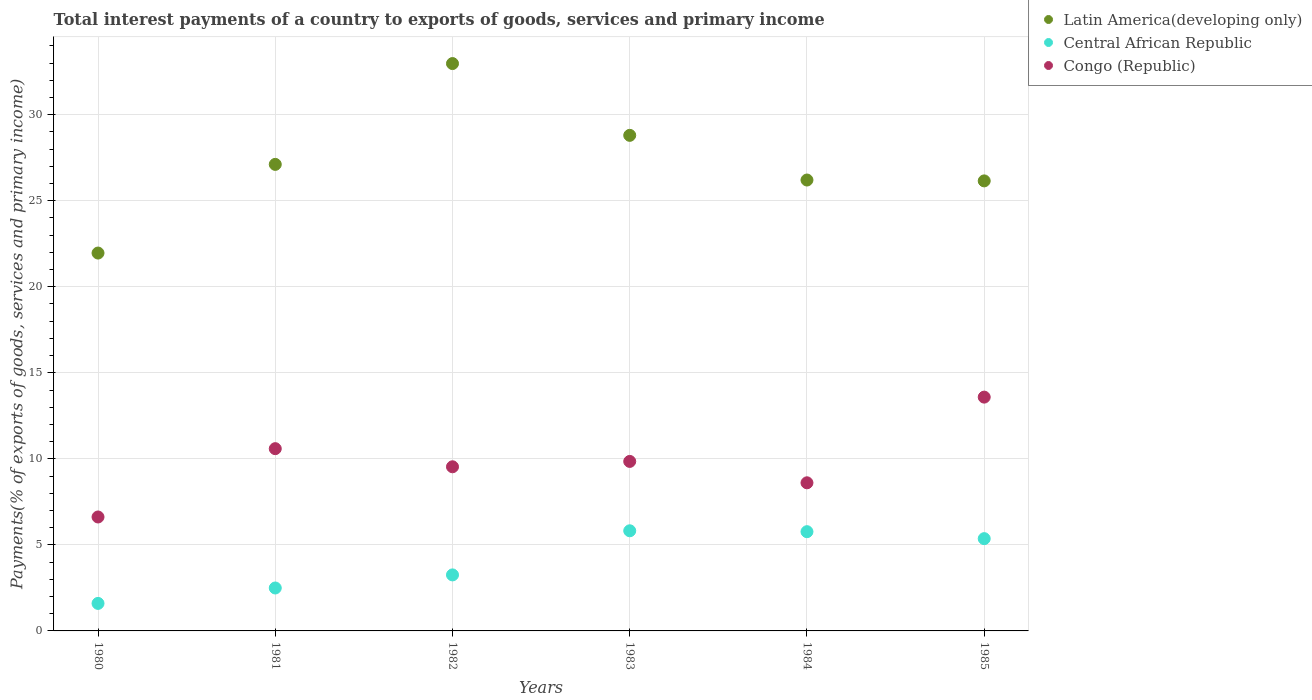What is the total interest payments in Central African Republic in 1984?
Offer a terse response. 5.77. Across all years, what is the maximum total interest payments in Congo (Republic)?
Your response must be concise. 13.59. Across all years, what is the minimum total interest payments in Latin America(developing only)?
Ensure brevity in your answer.  21.96. In which year was the total interest payments in Congo (Republic) minimum?
Your answer should be very brief. 1980. What is the total total interest payments in Congo (Republic) in the graph?
Give a very brief answer. 58.8. What is the difference between the total interest payments in Central African Republic in 1980 and that in 1981?
Your response must be concise. -0.9. What is the difference between the total interest payments in Congo (Republic) in 1984 and the total interest payments in Central African Republic in 1981?
Offer a very short reply. 6.11. What is the average total interest payments in Central African Republic per year?
Your response must be concise. 4.05. In the year 1980, what is the difference between the total interest payments in Latin America(developing only) and total interest payments in Congo (Republic)?
Give a very brief answer. 15.34. In how many years, is the total interest payments in Central African Republic greater than 22 %?
Provide a short and direct response. 0. What is the ratio of the total interest payments in Central African Republic in 1984 to that in 1985?
Give a very brief answer. 1.08. Is the total interest payments in Congo (Republic) in 1980 less than that in 1985?
Your response must be concise. Yes. Is the difference between the total interest payments in Latin America(developing only) in 1982 and 1985 greater than the difference between the total interest payments in Congo (Republic) in 1982 and 1985?
Ensure brevity in your answer.  Yes. What is the difference between the highest and the second highest total interest payments in Latin America(developing only)?
Provide a succinct answer. 4.17. What is the difference between the highest and the lowest total interest payments in Congo (Republic)?
Keep it short and to the point. 6.97. In how many years, is the total interest payments in Latin America(developing only) greater than the average total interest payments in Latin America(developing only) taken over all years?
Offer a very short reply. 2. Is it the case that in every year, the sum of the total interest payments in Central African Republic and total interest payments in Latin America(developing only)  is greater than the total interest payments in Congo (Republic)?
Offer a very short reply. Yes. Does the total interest payments in Central African Republic monotonically increase over the years?
Your response must be concise. No. Is the total interest payments in Latin America(developing only) strictly less than the total interest payments in Central African Republic over the years?
Make the answer very short. No. Does the graph contain any zero values?
Provide a succinct answer. No. Where does the legend appear in the graph?
Provide a succinct answer. Top right. How many legend labels are there?
Ensure brevity in your answer.  3. How are the legend labels stacked?
Offer a very short reply. Vertical. What is the title of the graph?
Your response must be concise. Total interest payments of a country to exports of goods, services and primary income. What is the label or title of the X-axis?
Provide a succinct answer. Years. What is the label or title of the Y-axis?
Give a very brief answer. Payments(% of exports of goods, services and primary income). What is the Payments(% of exports of goods, services and primary income) in Latin America(developing only) in 1980?
Give a very brief answer. 21.96. What is the Payments(% of exports of goods, services and primary income) of Central African Republic in 1980?
Offer a very short reply. 1.6. What is the Payments(% of exports of goods, services and primary income) of Congo (Republic) in 1980?
Provide a short and direct response. 6.62. What is the Payments(% of exports of goods, services and primary income) of Latin America(developing only) in 1981?
Your response must be concise. 27.11. What is the Payments(% of exports of goods, services and primary income) in Central African Republic in 1981?
Provide a succinct answer. 2.5. What is the Payments(% of exports of goods, services and primary income) of Congo (Republic) in 1981?
Your answer should be very brief. 10.59. What is the Payments(% of exports of goods, services and primary income) of Latin America(developing only) in 1982?
Offer a very short reply. 32.97. What is the Payments(% of exports of goods, services and primary income) of Central African Republic in 1982?
Make the answer very short. 3.26. What is the Payments(% of exports of goods, services and primary income) in Congo (Republic) in 1982?
Offer a very short reply. 9.54. What is the Payments(% of exports of goods, services and primary income) in Latin America(developing only) in 1983?
Your answer should be very brief. 28.8. What is the Payments(% of exports of goods, services and primary income) in Central African Republic in 1983?
Offer a very short reply. 5.82. What is the Payments(% of exports of goods, services and primary income) in Congo (Republic) in 1983?
Provide a succinct answer. 9.85. What is the Payments(% of exports of goods, services and primary income) of Latin America(developing only) in 1984?
Give a very brief answer. 26.2. What is the Payments(% of exports of goods, services and primary income) of Central African Republic in 1984?
Ensure brevity in your answer.  5.77. What is the Payments(% of exports of goods, services and primary income) of Congo (Republic) in 1984?
Make the answer very short. 8.61. What is the Payments(% of exports of goods, services and primary income) in Latin America(developing only) in 1985?
Ensure brevity in your answer.  26.15. What is the Payments(% of exports of goods, services and primary income) in Central African Republic in 1985?
Offer a terse response. 5.36. What is the Payments(% of exports of goods, services and primary income) of Congo (Republic) in 1985?
Your answer should be compact. 13.59. Across all years, what is the maximum Payments(% of exports of goods, services and primary income) in Latin America(developing only)?
Your answer should be compact. 32.97. Across all years, what is the maximum Payments(% of exports of goods, services and primary income) of Central African Republic?
Provide a succinct answer. 5.82. Across all years, what is the maximum Payments(% of exports of goods, services and primary income) of Congo (Republic)?
Keep it short and to the point. 13.59. Across all years, what is the minimum Payments(% of exports of goods, services and primary income) in Latin America(developing only)?
Your answer should be compact. 21.96. Across all years, what is the minimum Payments(% of exports of goods, services and primary income) of Central African Republic?
Ensure brevity in your answer.  1.6. Across all years, what is the minimum Payments(% of exports of goods, services and primary income) in Congo (Republic)?
Offer a very short reply. 6.62. What is the total Payments(% of exports of goods, services and primary income) of Latin America(developing only) in the graph?
Your response must be concise. 163.21. What is the total Payments(% of exports of goods, services and primary income) of Central African Republic in the graph?
Your response must be concise. 24.3. What is the total Payments(% of exports of goods, services and primary income) of Congo (Republic) in the graph?
Make the answer very short. 58.8. What is the difference between the Payments(% of exports of goods, services and primary income) in Latin America(developing only) in 1980 and that in 1981?
Your answer should be very brief. -5.15. What is the difference between the Payments(% of exports of goods, services and primary income) in Central African Republic in 1980 and that in 1981?
Ensure brevity in your answer.  -0.9. What is the difference between the Payments(% of exports of goods, services and primary income) in Congo (Republic) in 1980 and that in 1981?
Your answer should be very brief. -3.97. What is the difference between the Payments(% of exports of goods, services and primary income) in Latin America(developing only) in 1980 and that in 1982?
Give a very brief answer. -11.01. What is the difference between the Payments(% of exports of goods, services and primary income) of Central African Republic in 1980 and that in 1982?
Your answer should be very brief. -1.66. What is the difference between the Payments(% of exports of goods, services and primary income) of Congo (Republic) in 1980 and that in 1982?
Your answer should be compact. -2.92. What is the difference between the Payments(% of exports of goods, services and primary income) in Latin America(developing only) in 1980 and that in 1983?
Offer a terse response. -6.84. What is the difference between the Payments(% of exports of goods, services and primary income) of Central African Republic in 1980 and that in 1983?
Your answer should be compact. -4.22. What is the difference between the Payments(% of exports of goods, services and primary income) of Congo (Republic) in 1980 and that in 1983?
Offer a terse response. -3.23. What is the difference between the Payments(% of exports of goods, services and primary income) of Latin America(developing only) in 1980 and that in 1984?
Ensure brevity in your answer.  -4.24. What is the difference between the Payments(% of exports of goods, services and primary income) in Central African Republic in 1980 and that in 1984?
Ensure brevity in your answer.  -4.17. What is the difference between the Payments(% of exports of goods, services and primary income) in Congo (Republic) in 1980 and that in 1984?
Ensure brevity in your answer.  -1.99. What is the difference between the Payments(% of exports of goods, services and primary income) of Latin America(developing only) in 1980 and that in 1985?
Provide a succinct answer. -4.19. What is the difference between the Payments(% of exports of goods, services and primary income) of Central African Republic in 1980 and that in 1985?
Your answer should be compact. -3.76. What is the difference between the Payments(% of exports of goods, services and primary income) of Congo (Republic) in 1980 and that in 1985?
Ensure brevity in your answer.  -6.97. What is the difference between the Payments(% of exports of goods, services and primary income) in Latin America(developing only) in 1981 and that in 1982?
Offer a very short reply. -5.86. What is the difference between the Payments(% of exports of goods, services and primary income) of Central African Republic in 1981 and that in 1982?
Your response must be concise. -0.76. What is the difference between the Payments(% of exports of goods, services and primary income) in Congo (Republic) in 1981 and that in 1982?
Your answer should be very brief. 1.05. What is the difference between the Payments(% of exports of goods, services and primary income) of Latin America(developing only) in 1981 and that in 1983?
Offer a very short reply. -1.69. What is the difference between the Payments(% of exports of goods, services and primary income) of Central African Republic in 1981 and that in 1983?
Give a very brief answer. -3.32. What is the difference between the Payments(% of exports of goods, services and primary income) in Congo (Republic) in 1981 and that in 1983?
Offer a very short reply. 0.74. What is the difference between the Payments(% of exports of goods, services and primary income) of Central African Republic in 1981 and that in 1984?
Offer a terse response. -3.27. What is the difference between the Payments(% of exports of goods, services and primary income) of Congo (Republic) in 1981 and that in 1984?
Provide a succinct answer. 1.98. What is the difference between the Payments(% of exports of goods, services and primary income) of Latin America(developing only) in 1981 and that in 1985?
Offer a very short reply. 0.96. What is the difference between the Payments(% of exports of goods, services and primary income) of Central African Republic in 1981 and that in 1985?
Your answer should be compact. -2.87. What is the difference between the Payments(% of exports of goods, services and primary income) in Congo (Republic) in 1981 and that in 1985?
Keep it short and to the point. -3. What is the difference between the Payments(% of exports of goods, services and primary income) in Latin America(developing only) in 1982 and that in 1983?
Offer a very short reply. 4.17. What is the difference between the Payments(% of exports of goods, services and primary income) in Central African Republic in 1982 and that in 1983?
Ensure brevity in your answer.  -2.56. What is the difference between the Payments(% of exports of goods, services and primary income) in Congo (Republic) in 1982 and that in 1983?
Offer a terse response. -0.31. What is the difference between the Payments(% of exports of goods, services and primary income) of Latin America(developing only) in 1982 and that in 1984?
Keep it short and to the point. 6.77. What is the difference between the Payments(% of exports of goods, services and primary income) of Central African Republic in 1982 and that in 1984?
Your answer should be compact. -2.51. What is the difference between the Payments(% of exports of goods, services and primary income) in Congo (Republic) in 1982 and that in 1984?
Provide a succinct answer. 0.93. What is the difference between the Payments(% of exports of goods, services and primary income) in Latin America(developing only) in 1982 and that in 1985?
Offer a very short reply. 6.82. What is the difference between the Payments(% of exports of goods, services and primary income) in Central African Republic in 1982 and that in 1985?
Your answer should be compact. -2.11. What is the difference between the Payments(% of exports of goods, services and primary income) of Congo (Republic) in 1982 and that in 1985?
Give a very brief answer. -4.05. What is the difference between the Payments(% of exports of goods, services and primary income) of Latin America(developing only) in 1983 and that in 1984?
Make the answer very short. 2.6. What is the difference between the Payments(% of exports of goods, services and primary income) of Central African Republic in 1983 and that in 1984?
Offer a very short reply. 0.05. What is the difference between the Payments(% of exports of goods, services and primary income) in Congo (Republic) in 1983 and that in 1984?
Your answer should be compact. 1.24. What is the difference between the Payments(% of exports of goods, services and primary income) of Latin America(developing only) in 1983 and that in 1985?
Provide a succinct answer. 2.65. What is the difference between the Payments(% of exports of goods, services and primary income) in Central African Republic in 1983 and that in 1985?
Ensure brevity in your answer.  0.46. What is the difference between the Payments(% of exports of goods, services and primary income) of Congo (Republic) in 1983 and that in 1985?
Provide a short and direct response. -3.74. What is the difference between the Payments(% of exports of goods, services and primary income) of Latin America(developing only) in 1984 and that in 1985?
Provide a succinct answer. 0.05. What is the difference between the Payments(% of exports of goods, services and primary income) of Central African Republic in 1984 and that in 1985?
Ensure brevity in your answer.  0.4. What is the difference between the Payments(% of exports of goods, services and primary income) of Congo (Republic) in 1984 and that in 1985?
Offer a terse response. -4.98. What is the difference between the Payments(% of exports of goods, services and primary income) of Latin America(developing only) in 1980 and the Payments(% of exports of goods, services and primary income) of Central African Republic in 1981?
Ensure brevity in your answer.  19.47. What is the difference between the Payments(% of exports of goods, services and primary income) in Latin America(developing only) in 1980 and the Payments(% of exports of goods, services and primary income) in Congo (Republic) in 1981?
Your answer should be compact. 11.37. What is the difference between the Payments(% of exports of goods, services and primary income) of Central African Republic in 1980 and the Payments(% of exports of goods, services and primary income) of Congo (Republic) in 1981?
Your answer should be very brief. -8.99. What is the difference between the Payments(% of exports of goods, services and primary income) of Latin America(developing only) in 1980 and the Payments(% of exports of goods, services and primary income) of Central African Republic in 1982?
Provide a succinct answer. 18.71. What is the difference between the Payments(% of exports of goods, services and primary income) of Latin America(developing only) in 1980 and the Payments(% of exports of goods, services and primary income) of Congo (Republic) in 1982?
Offer a very short reply. 12.42. What is the difference between the Payments(% of exports of goods, services and primary income) in Central African Republic in 1980 and the Payments(% of exports of goods, services and primary income) in Congo (Republic) in 1982?
Make the answer very short. -7.94. What is the difference between the Payments(% of exports of goods, services and primary income) of Latin America(developing only) in 1980 and the Payments(% of exports of goods, services and primary income) of Central African Republic in 1983?
Provide a short and direct response. 16.14. What is the difference between the Payments(% of exports of goods, services and primary income) in Latin America(developing only) in 1980 and the Payments(% of exports of goods, services and primary income) in Congo (Republic) in 1983?
Your response must be concise. 12.11. What is the difference between the Payments(% of exports of goods, services and primary income) of Central African Republic in 1980 and the Payments(% of exports of goods, services and primary income) of Congo (Republic) in 1983?
Ensure brevity in your answer.  -8.25. What is the difference between the Payments(% of exports of goods, services and primary income) of Latin America(developing only) in 1980 and the Payments(% of exports of goods, services and primary income) of Central African Republic in 1984?
Your answer should be very brief. 16.19. What is the difference between the Payments(% of exports of goods, services and primary income) in Latin America(developing only) in 1980 and the Payments(% of exports of goods, services and primary income) in Congo (Republic) in 1984?
Provide a succinct answer. 13.35. What is the difference between the Payments(% of exports of goods, services and primary income) in Central African Republic in 1980 and the Payments(% of exports of goods, services and primary income) in Congo (Republic) in 1984?
Your response must be concise. -7.01. What is the difference between the Payments(% of exports of goods, services and primary income) in Latin America(developing only) in 1980 and the Payments(% of exports of goods, services and primary income) in Central African Republic in 1985?
Provide a short and direct response. 16.6. What is the difference between the Payments(% of exports of goods, services and primary income) of Latin America(developing only) in 1980 and the Payments(% of exports of goods, services and primary income) of Congo (Republic) in 1985?
Give a very brief answer. 8.37. What is the difference between the Payments(% of exports of goods, services and primary income) in Central African Republic in 1980 and the Payments(% of exports of goods, services and primary income) in Congo (Republic) in 1985?
Ensure brevity in your answer.  -11.99. What is the difference between the Payments(% of exports of goods, services and primary income) of Latin America(developing only) in 1981 and the Payments(% of exports of goods, services and primary income) of Central African Republic in 1982?
Offer a very short reply. 23.86. What is the difference between the Payments(% of exports of goods, services and primary income) in Latin America(developing only) in 1981 and the Payments(% of exports of goods, services and primary income) in Congo (Republic) in 1982?
Your answer should be compact. 17.57. What is the difference between the Payments(% of exports of goods, services and primary income) of Central African Republic in 1981 and the Payments(% of exports of goods, services and primary income) of Congo (Republic) in 1982?
Make the answer very short. -7.04. What is the difference between the Payments(% of exports of goods, services and primary income) in Latin America(developing only) in 1981 and the Payments(% of exports of goods, services and primary income) in Central African Republic in 1983?
Provide a succinct answer. 21.29. What is the difference between the Payments(% of exports of goods, services and primary income) in Latin America(developing only) in 1981 and the Payments(% of exports of goods, services and primary income) in Congo (Republic) in 1983?
Provide a succinct answer. 17.26. What is the difference between the Payments(% of exports of goods, services and primary income) of Central African Republic in 1981 and the Payments(% of exports of goods, services and primary income) of Congo (Republic) in 1983?
Your answer should be compact. -7.36. What is the difference between the Payments(% of exports of goods, services and primary income) in Latin America(developing only) in 1981 and the Payments(% of exports of goods, services and primary income) in Central African Republic in 1984?
Your answer should be very brief. 21.35. What is the difference between the Payments(% of exports of goods, services and primary income) of Latin America(developing only) in 1981 and the Payments(% of exports of goods, services and primary income) of Congo (Republic) in 1984?
Make the answer very short. 18.51. What is the difference between the Payments(% of exports of goods, services and primary income) of Central African Republic in 1981 and the Payments(% of exports of goods, services and primary income) of Congo (Republic) in 1984?
Provide a short and direct response. -6.11. What is the difference between the Payments(% of exports of goods, services and primary income) in Latin America(developing only) in 1981 and the Payments(% of exports of goods, services and primary income) in Central African Republic in 1985?
Your answer should be compact. 21.75. What is the difference between the Payments(% of exports of goods, services and primary income) of Latin America(developing only) in 1981 and the Payments(% of exports of goods, services and primary income) of Congo (Republic) in 1985?
Make the answer very short. 13.53. What is the difference between the Payments(% of exports of goods, services and primary income) of Central African Republic in 1981 and the Payments(% of exports of goods, services and primary income) of Congo (Republic) in 1985?
Provide a short and direct response. -11.09. What is the difference between the Payments(% of exports of goods, services and primary income) in Latin America(developing only) in 1982 and the Payments(% of exports of goods, services and primary income) in Central African Republic in 1983?
Ensure brevity in your answer.  27.15. What is the difference between the Payments(% of exports of goods, services and primary income) in Latin America(developing only) in 1982 and the Payments(% of exports of goods, services and primary income) in Congo (Republic) in 1983?
Give a very brief answer. 23.12. What is the difference between the Payments(% of exports of goods, services and primary income) of Central African Republic in 1982 and the Payments(% of exports of goods, services and primary income) of Congo (Republic) in 1983?
Keep it short and to the point. -6.6. What is the difference between the Payments(% of exports of goods, services and primary income) in Latin America(developing only) in 1982 and the Payments(% of exports of goods, services and primary income) in Central African Republic in 1984?
Your answer should be very brief. 27.21. What is the difference between the Payments(% of exports of goods, services and primary income) in Latin America(developing only) in 1982 and the Payments(% of exports of goods, services and primary income) in Congo (Republic) in 1984?
Offer a very short reply. 24.37. What is the difference between the Payments(% of exports of goods, services and primary income) in Central African Republic in 1982 and the Payments(% of exports of goods, services and primary income) in Congo (Republic) in 1984?
Make the answer very short. -5.35. What is the difference between the Payments(% of exports of goods, services and primary income) in Latin America(developing only) in 1982 and the Payments(% of exports of goods, services and primary income) in Central African Republic in 1985?
Keep it short and to the point. 27.61. What is the difference between the Payments(% of exports of goods, services and primary income) of Latin America(developing only) in 1982 and the Payments(% of exports of goods, services and primary income) of Congo (Republic) in 1985?
Your answer should be compact. 19.39. What is the difference between the Payments(% of exports of goods, services and primary income) of Central African Republic in 1982 and the Payments(% of exports of goods, services and primary income) of Congo (Republic) in 1985?
Your answer should be compact. -10.33. What is the difference between the Payments(% of exports of goods, services and primary income) of Latin America(developing only) in 1983 and the Payments(% of exports of goods, services and primary income) of Central African Republic in 1984?
Provide a short and direct response. 23.03. What is the difference between the Payments(% of exports of goods, services and primary income) of Latin America(developing only) in 1983 and the Payments(% of exports of goods, services and primary income) of Congo (Republic) in 1984?
Make the answer very short. 20.19. What is the difference between the Payments(% of exports of goods, services and primary income) of Central African Republic in 1983 and the Payments(% of exports of goods, services and primary income) of Congo (Republic) in 1984?
Your answer should be compact. -2.79. What is the difference between the Payments(% of exports of goods, services and primary income) in Latin America(developing only) in 1983 and the Payments(% of exports of goods, services and primary income) in Central African Republic in 1985?
Give a very brief answer. 23.44. What is the difference between the Payments(% of exports of goods, services and primary income) of Latin America(developing only) in 1983 and the Payments(% of exports of goods, services and primary income) of Congo (Republic) in 1985?
Your answer should be very brief. 15.21. What is the difference between the Payments(% of exports of goods, services and primary income) of Central African Republic in 1983 and the Payments(% of exports of goods, services and primary income) of Congo (Republic) in 1985?
Your response must be concise. -7.77. What is the difference between the Payments(% of exports of goods, services and primary income) of Latin America(developing only) in 1984 and the Payments(% of exports of goods, services and primary income) of Central African Republic in 1985?
Provide a short and direct response. 20.84. What is the difference between the Payments(% of exports of goods, services and primary income) of Latin America(developing only) in 1984 and the Payments(% of exports of goods, services and primary income) of Congo (Republic) in 1985?
Provide a short and direct response. 12.62. What is the difference between the Payments(% of exports of goods, services and primary income) in Central African Republic in 1984 and the Payments(% of exports of goods, services and primary income) in Congo (Republic) in 1985?
Offer a terse response. -7.82. What is the average Payments(% of exports of goods, services and primary income) in Latin America(developing only) per year?
Make the answer very short. 27.2. What is the average Payments(% of exports of goods, services and primary income) in Central African Republic per year?
Offer a very short reply. 4.05. What is the average Payments(% of exports of goods, services and primary income) of Congo (Republic) per year?
Ensure brevity in your answer.  9.8. In the year 1980, what is the difference between the Payments(% of exports of goods, services and primary income) of Latin America(developing only) and Payments(% of exports of goods, services and primary income) of Central African Republic?
Your response must be concise. 20.36. In the year 1980, what is the difference between the Payments(% of exports of goods, services and primary income) of Latin America(developing only) and Payments(% of exports of goods, services and primary income) of Congo (Republic)?
Offer a terse response. 15.34. In the year 1980, what is the difference between the Payments(% of exports of goods, services and primary income) in Central African Republic and Payments(% of exports of goods, services and primary income) in Congo (Republic)?
Offer a very short reply. -5.02. In the year 1981, what is the difference between the Payments(% of exports of goods, services and primary income) in Latin America(developing only) and Payments(% of exports of goods, services and primary income) in Central African Republic?
Keep it short and to the point. 24.62. In the year 1981, what is the difference between the Payments(% of exports of goods, services and primary income) of Latin America(developing only) and Payments(% of exports of goods, services and primary income) of Congo (Republic)?
Provide a succinct answer. 16.52. In the year 1981, what is the difference between the Payments(% of exports of goods, services and primary income) in Central African Republic and Payments(% of exports of goods, services and primary income) in Congo (Republic)?
Give a very brief answer. -8.1. In the year 1982, what is the difference between the Payments(% of exports of goods, services and primary income) in Latin America(developing only) and Payments(% of exports of goods, services and primary income) in Central African Republic?
Provide a succinct answer. 29.72. In the year 1982, what is the difference between the Payments(% of exports of goods, services and primary income) in Latin America(developing only) and Payments(% of exports of goods, services and primary income) in Congo (Republic)?
Provide a short and direct response. 23.43. In the year 1982, what is the difference between the Payments(% of exports of goods, services and primary income) in Central African Republic and Payments(% of exports of goods, services and primary income) in Congo (Republic)?
Offer a very short reply. -6.28. In the year 1983, what is the difference between the Payments(% of exports of goods, services and primary income) of Latin America(developing only) and Payments(% of exports of goods, services and primary income) of Central African Republic?
Give a very brief answer. 22.98. In the year 1983, what is the difference between the Payments(% of exports of goods, services and primary income) of Latin America(developing only) and Payments(% of exports of goods, services and primary income) of Congo (Republic)?
Offer a very short reply. 18.95. In the year 1983, what is the difference between the Payments(% of exports of goods, services and primary income) in Central African Republic and Payments(% of exports of goods, services and primary income) in Congo (Republic)?
Your answer should be compact. -4.03. In the year 1984, what is the difference between the Payments(% of exports of goods, services and primary income) of Latin America(developing only) and Payments(% of exports of goods, services and primary income) of Central African Republic?
Ensure brevity in your answer.  20.44. In the year 1984, what is the difference between the Payments(% of exports of goods, services and primary income) in Latin America(developing only) and Payments(% of exports of goods, services and primary income) in Congo (Republic)?
Offer a terse response. 17.6. In the year 1984, what is the difference between the Payments(% of exports of goods, services and primary income) in Central African Republic and Payments(% of exports of goods, services and primary income) in Congo (Republic)?
Your answer should be compact. -2.84. In the year 1985, what is the difference between the Payments(% of exports of goods, services and primary income) in Latin America(developing only) and Payments(% of exports of goods, services and primary income) in Central African Republic?
Offer a very short reply. 20.79. In the year 1985, what is the difference between the Payments(% of exports of goods, services and primary income) in Latin America(developing only) and Payments(% of exports of goods, services and primary income) in Congo (Republic)?
Ensure brevity in your answer.  12.57. In the year 1985, what is the difference between the Payments(% of exports of goods, services and primary income) in Central African Republic and Payments(% of exports of goods, services and primary income) in Congo (Republic)?
Your answer should be compact. -8.23. What is the ratio of the Payments(% of exports of goods, services and primary income) of Latin America(developing only) in 1980 to that in 1981?
Your response must be concise. 0.81. What is the ratio of the Payments(% of exports of goods, services and primary income) of Central African Republic in 1980 to that in 1981?
Keep it short and to the point. 0.64. What is the ratio of the Payments(% of exports of goods, services and primary income) in Congo (Republic) in 1980 to that in 1981?
Ensure brevity in your answer.  0.63. What is the ratio of the Payments(% of exports of goods, services and primary income) of Latin America(developing only) in 1980 to that in 1982?
Your answer should be compact. 0.67. What is the ratio of the Payments(% of exports of goods, services and primary income) in Central African Republic in 1980 to that in 1982?
Your answer should be very brief. 0.49. What is the ratio of the Payments(% of exports of goods, services and primary income) of Congo (Republic) in 1980 to that in 1982?
Provide a succinct answer. 0.69. What is the ratio of the Payments(% of exports of goods, services and primary income) in Latin America(developing only) in 1980 to that in 1983?
Make the answer very short. 0.76. What is the ratio of the Payments(% of exports of goods, services and primary income) in Central African Republic in 1980 to that in 1983?
Your answer should be compact. 0.27. What is the ratio of the Payments(% of exports of goods, services and primary income) in Congo (Republic) in 1980 to that in 1983?
Ensure brevity in your answer.  0.67. What is the ratio of the Payments(% of exports of goods, services and primary income) of Latin America(developing only) in 1980 to that in 1984?
Ensure brevity in your answer.  0.84. What is the ratio of the Payments(% of exports of goods, services and primary income) of Central African Republic in 1980 to that in 1984?
Provide a short and direct response. 0.28. What is the ratio of the Payments(% of exports of goods, services and primary income) in Congo (Republic) in 1980 to that in 1984?
Give a very brief answer. 0.77. What is the ratio of the Payments(% of exports of goods, services and primary income) in Latin America(developing only) in 1980 to that in 1985?
Offer a very short reply. 0.84. What is the ratio of the Payments(% of exports of goods, services and primary income) in Central African Republic in 1980 to that in 1985?
Ensure brevity in your answer.  0.3. What is the ratio of the Payments(% of exports of goods, services and primary income) of Congo (Republic) in 1980 to that in 1985?
Your response must be concise. 0.49. What is the ratio of the Payments(% of exports of goods, services and primary income) in Latin America(developing only) in 1981 to that in 1982?
Provide a short and direct response. 0.82. What is the ratio of the Payments(% of exports of goods, services and primary income) in Central African Republic in 1981 to that in 1982?
Keep it short and to the point. 0.77. What is the ratio of the Payments(% of exports of goods, services and primary income) in Congo (Republic) in 1981 to that in 1982?
Offer a very short reply. 1.11. What is the ratio of the Payments(% of exports of goods, services and primary income) in Latin America(developing only) in 1981 to that in 1983?
Give a very brief answer. 0.94. What is the ratio of the Payments(% of exports of goods, services and primary income) in Central African Republic in 1981 to that in 1983?
Your response must be concise. 0.43. What is the ratio of the Payments(% of exports of goods, services and primary income) in Congo (Republic) in 1981 to that in 1983?
Your answer should be very brief. 1.08. What is the ratio of the Payments(% of exports of goods, services and primary income) in Latin America(developing only) in 1981 to that in 1984?
Give a very brief answer. 1.03. What is the ratio of the Payments(% of exports of goods, services and primary income) of Central African Republic in 1981 to that in 1984?
Provide a succinct answer. 0.43. What is the ratio of the Payments(% of exports of goods, services and primary income) of Congo (Republic) in 1981 to that in 1984?
Give a very brief answer. 1.23. What is the ratio of the Payments(% of exports of goods, services and primary income) in Latin America(developing only) in 1981 to that in 1985?
Offer a very short reply. 1.04. What is the ratio of the Payments(% of exports of goods, services and primary income) of Central African Republic in 1981 to that in 1985?
Provide a short and direct response. 0.47. What is the ratio of the Payments(% of exports of goods, services and primary income) of Congo (Republic) in 1981 to that in 1985?
Give a very brief answer. 0.78. What is the ratio of the Payments(% of exports of goods, services and primary income) of Latin America(developing only) in 1982 to that in 1983?
Keep it short and to the point. 1.14. What is the ratio of the Payments(% of exports of goods, services and primary income) of Central African Republic in 1982 to that in 1983?
Provide a succinct answer. 0.56. What is the ratio of the Payments(% of exports of goods, services and primary income) in Congo (Republic) in 1982 to that in 1983?
Your answer should be very brief. 0.97. What is the ratio of the Payments(% of exports of goods, services and primary income) in Latin America(developing only) in 1982 to that in 1984?
Your response must be concise. 1.26. What is the ratio of the Payments(% of exports of goods, services and primary income) of Central African Republic in 1982 to that in 1984?
Give a very brief answer. 0.56. What is the ratio of the Payments(% of exports of goods, services and primary income) in Congo (Republic) in 1982 to that in 1984?
Offer a terse response. 1.11. What is the ratio of the Payments(% of exports of goods, services and primary income) of Latin America(developing only) in 1982 to that in 1985?
Keep it short and to the point. 1.26. What is the ratio of the Payments(% of exports of goods, services and primary income) in Central African Republic in 1982 to that in 1985?
Provide a succinct answer. 0.61. What is the ratio of the Payments(% of exports of goods, services and primary income) in Congo (Republic) in 1982 to that in 1985?
Offer a very short reply. 0.7. What is the ratio of the Payments(% of exports of goods, services and primary income) in Latin America(developing only) in 1983 to that in 1984?
Make the answer very short. 1.1. What is the ratio of the Payments(% of exports of goods, services and primary income) of Central African Republic in 1983 to that in 1984?
Provide a succinct answer. 1.01. What is the ratio of the Payments(% of exports of goods, services and primary income) in Congo (Republic) in 1983 to that in 1984?
Give a very brief answer. 1.14. What is the ratio of the Payments(% of exports of goods, services and primary income) in Latin America(developing only) in 1983 to that in 1985?
Ensure brevity in your answer.  1.1. What is the ratio of the Payments(% of exports of goods, services and primary income) in Central African Republic in 1983 to that in 1985?
Provide a succinct answer. 1.09. What is the ratio of the Payments(% of exports of goods, services and primary income) in Congo (Republic) in 1983 to that in 1985?
Offer a terse response. 0.72. What is the ratio of the Payments(% of exports of goods, services and primary income) of Central African Republic in 1984 to that in 1985?
Offer a very short reply. 1.08. What is the ratio of the Payments(% of exports of goods, services and primary income) of Congo (Republic) in 1984 to that in 1985?
Keep it short and to the point. 0.63. What is the difference between the highest and the second highest Payments(% of exports of goods, services and primary income) in Latin America(developing only)?
Your answer should be compact. 4.17. What is the difference between the highest and the second highest Payments(% of exports of goods, services and primary income) in Central African Republic?
Your answer should be very brief. 0.05. What is the difference between the highest and the second highest Payments(% of exports of goods, services and primary income) in Congo (Republic)?
Your answer should be very brief. 3. What is the difference between the highest and the lowest Payments(% of exports of goods, services and primary income) of Latin America(developing only)?
Your answer should be compact. 11.01. What is the difference between the highest and the lowest Payments(% of exports of goods, services and primary income) in Central African Republic?
Ensure brevity in your answer.  4.22. What is the difference between the highest and the lowest Payments(% of exports of goods, services and primary income) in Congo (Republic)?
Provide a short and direct response. 6.97. 